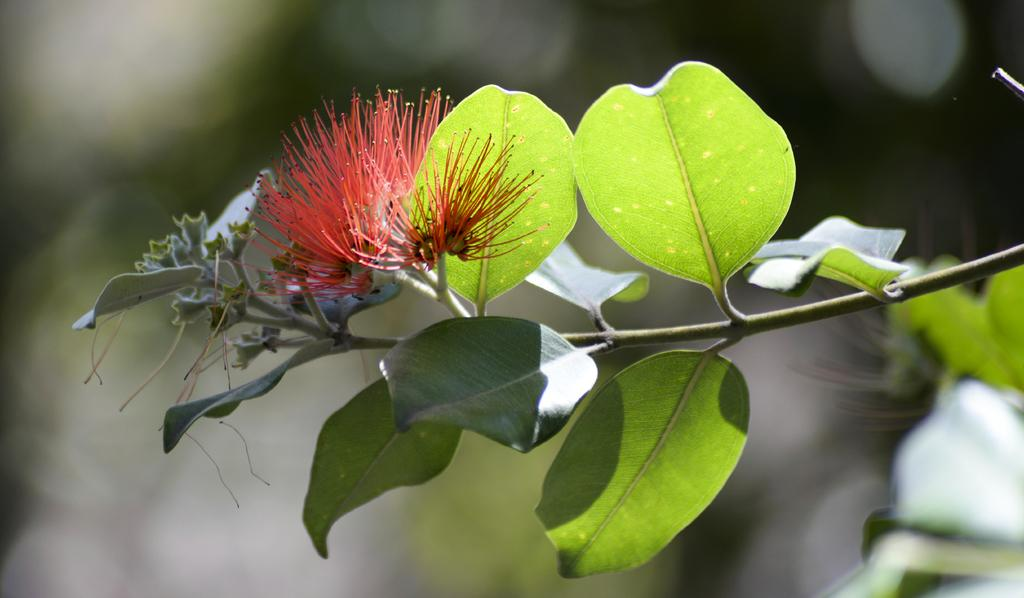What is the main subject of the image? The main subject of the image is a plant. What specific feature of the plant can be observed? The plant has flowers. Can you describe the background of the image? The background of the image is blurred. What type of theory is being proposed by the plant in the image? There is no indication in the image that the plant is proposing any theories. 